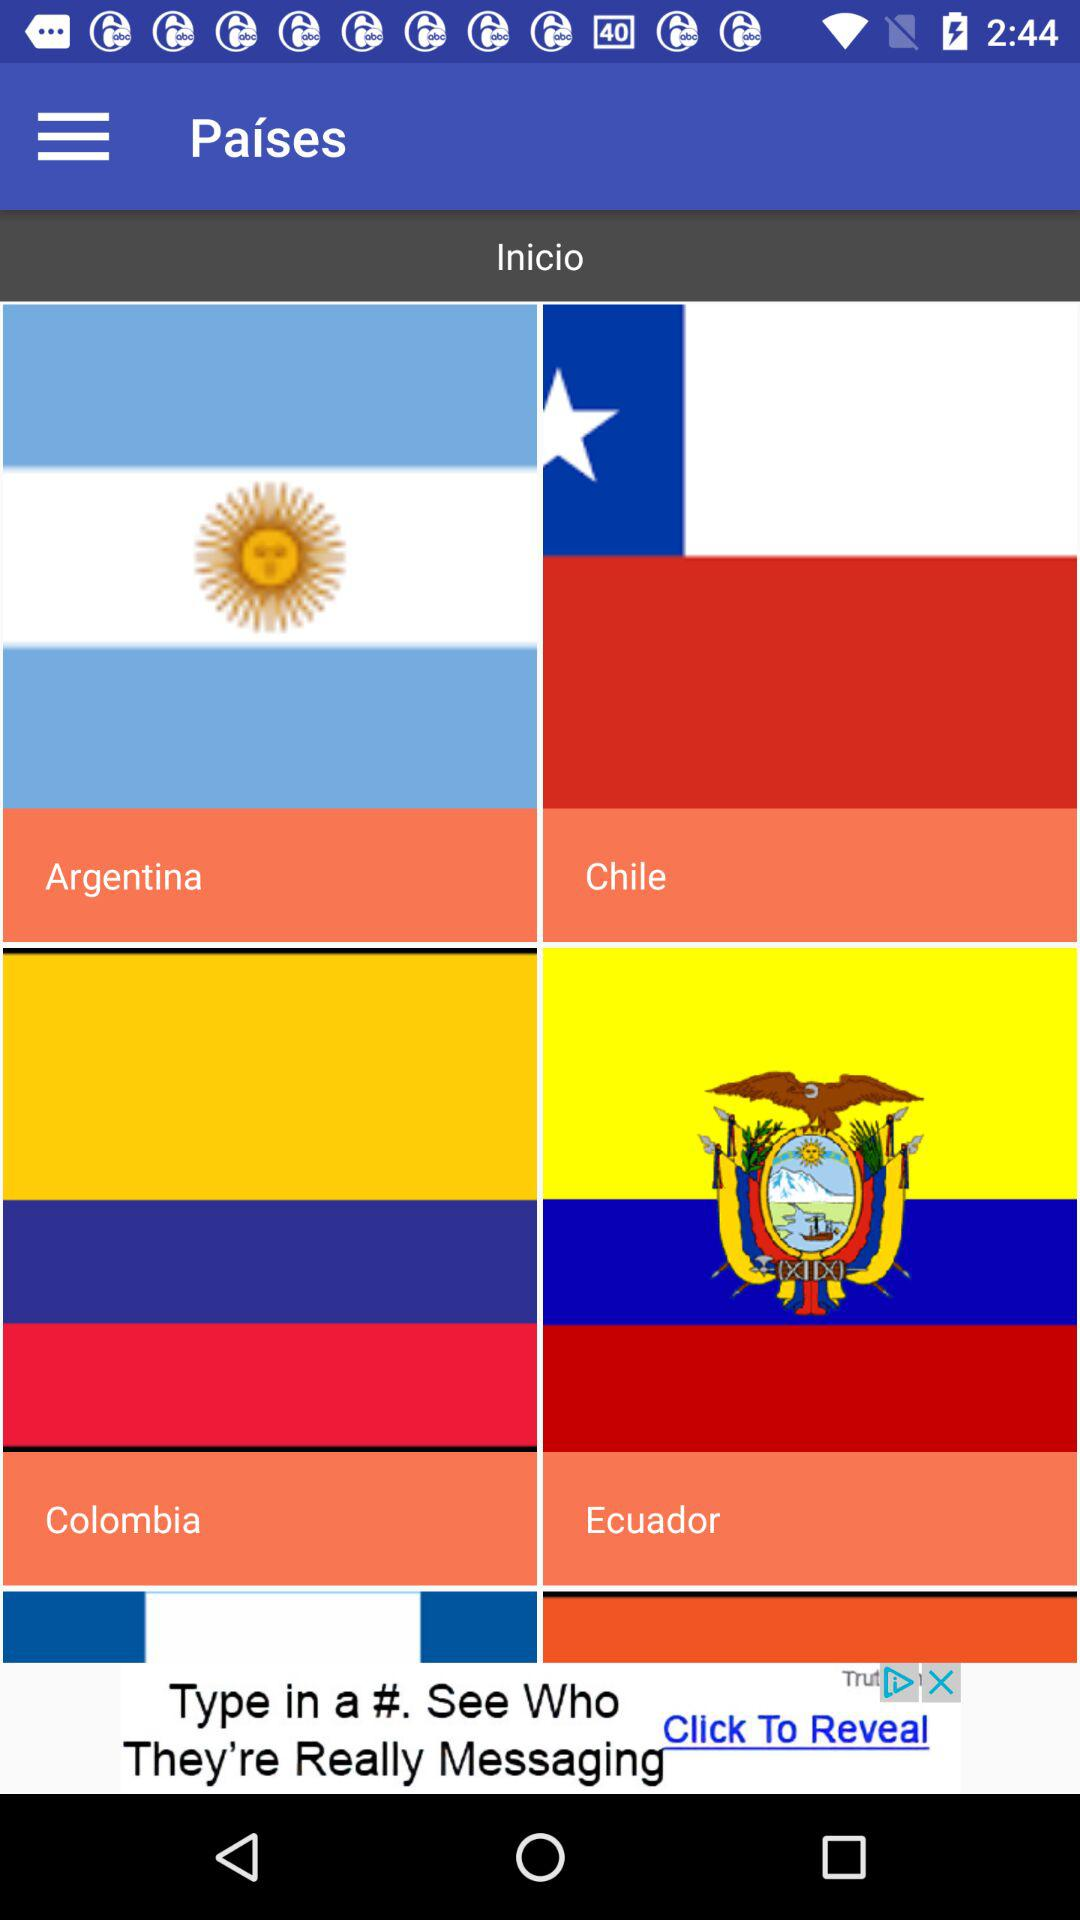Tell me a few names of countries in South America?
When the provided information is insufficient, respond with <no answer>. <no answer> 